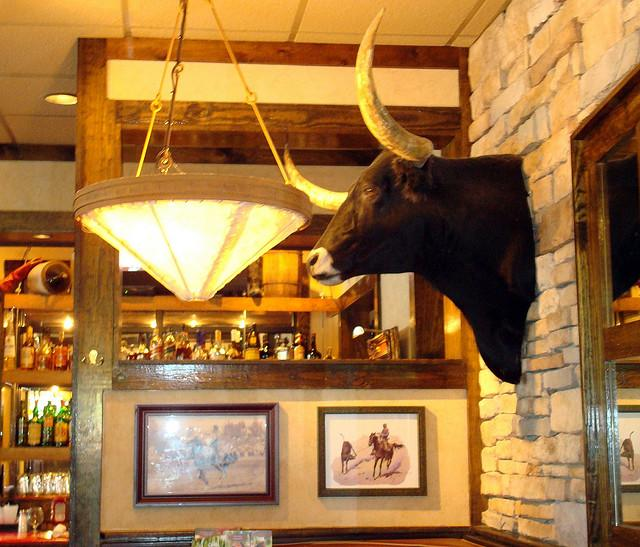What type of facility is displaying the animal head? Please explain your reasoning. bar. The bottles of booze in the back indicate that it is a tavern. 